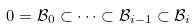Convert formula to latex. <formula><loc_0><loc_0><loc_500><loc_500>0 = \mathcal { B } _ { 0 } \subset \cdots \subset \mathcal { B } _ { i - 1 } \subset \mathcal { B } _ { i }</formula> 